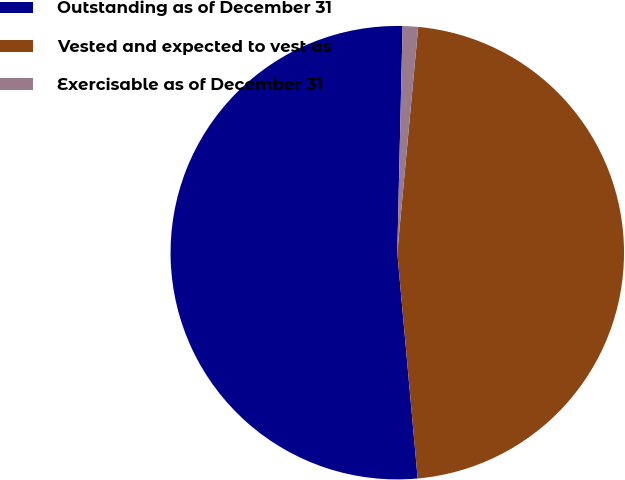<chart> <loc_0><loc_0><loc_500><loc_500><pie_chart><fcel>Outstanding as of December 31<fcel>Vested and expected to vest as<fcel>Exercisable as of December 31<nl><fcel>51.81%<fcel>47.1%<fcel>1.1%<nl></chart> 